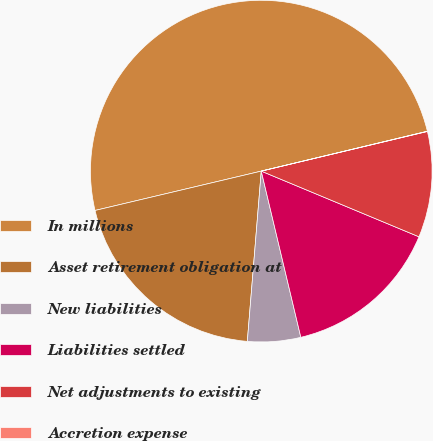<chart> <loc_0><loc_0><loc_500><loc_500><pie_chart><fcel>In millions<fcel>Asset retirement obligation at<fcel>New liabilities<fcel>Liabilities settled<fcel>Net adjustments to existing<fcel>Accretion expense<nl><fcel>49.95%<fcel>20.0%<fcel>5.02%<fcel>15.0%<fcel>10.01%<fcel>0.02%<nl></chart> 